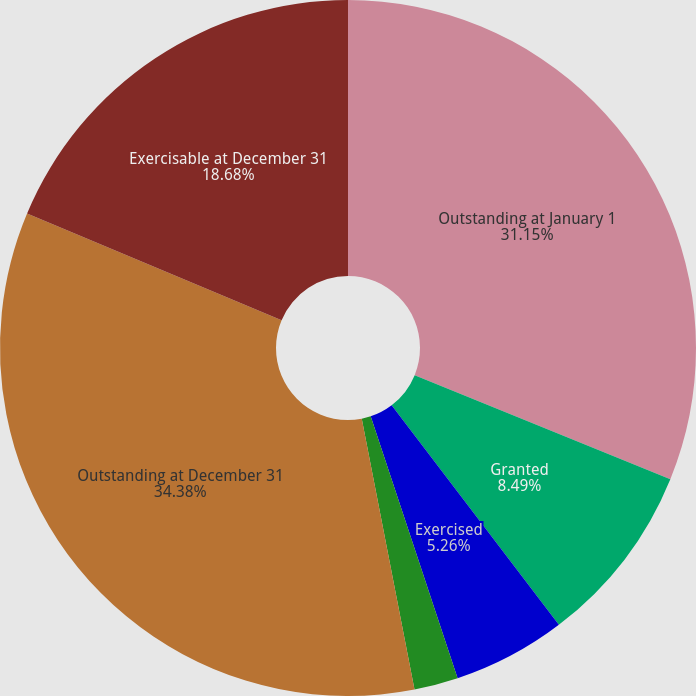Convert chart to OTSL. <chart><loc_0><loc_0><loc_500><loc_500><pie_chart><fcel>Outstanding at January 1<fcel>Granted<fcel>Exercised<fcel>Forfeited or expired<fcel>Outstanding at December 31<fcel>Exercisable at December 31<nl><fcel>31.15%<fcel>8.49%<fcel>5.26%<fcel>2.04%<fcel>34.38%<fcel>18.68%<nl></chart> 